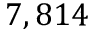<formula> <loc_0><loc_0><loc_500><loc_500>7 , 8 1 4</formula> 